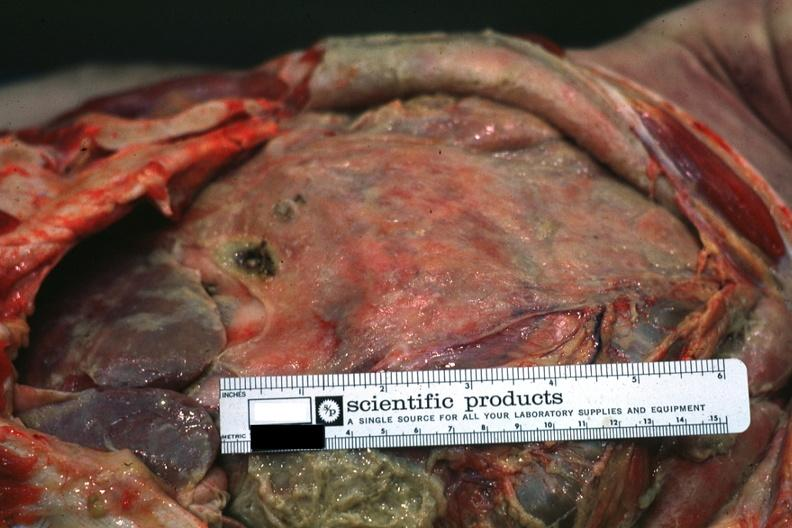what is intestines covered?
Answer the question using a single word or phrase. By fibrinopurulent membrane due to ruptured peptic ulcer 